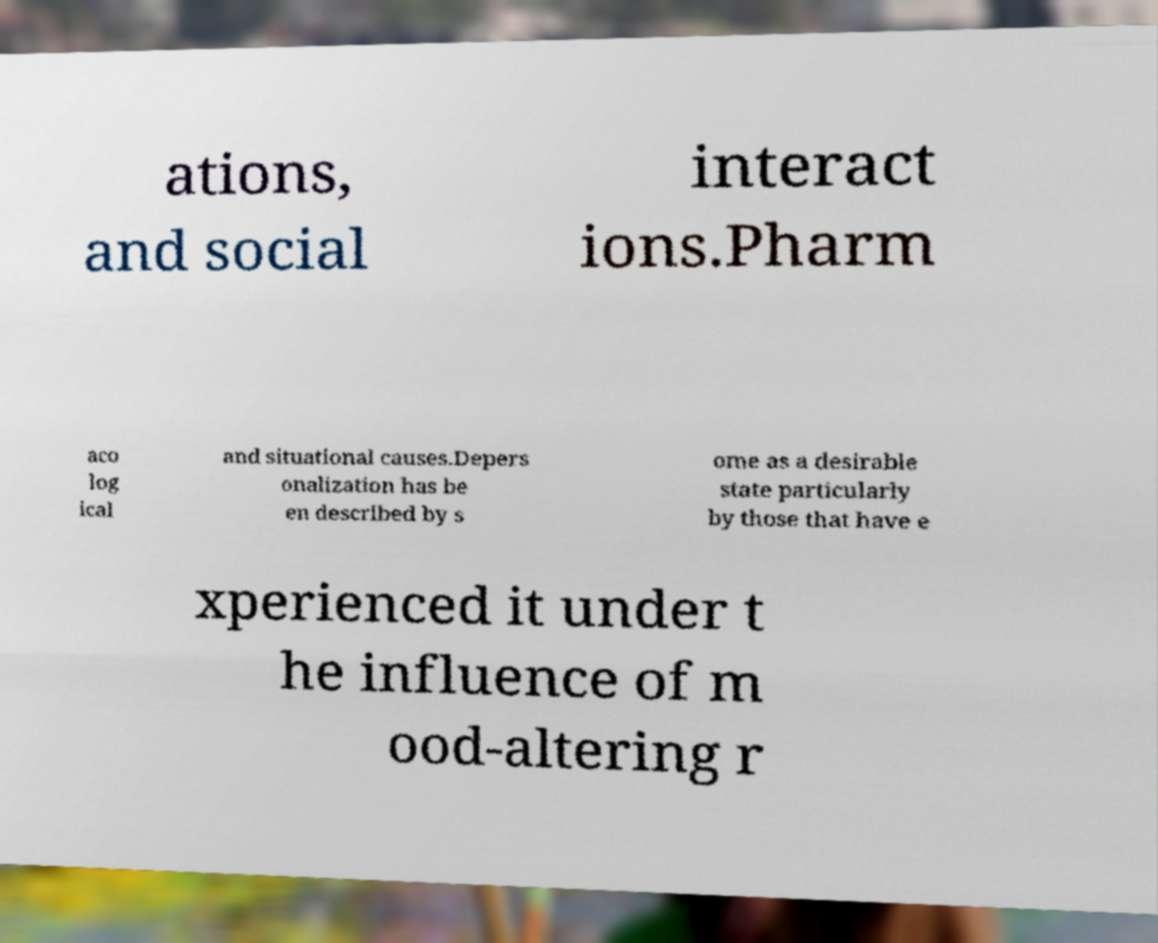There's text embedded in this image that I need extracted. Can you transcribe it verbatim? ations, and social interact ions.Pharm aco log ical and situational causes.Depers onalization has be en described by s ome as a desirable state particularly by those that have e xperienced it under t he influence of m ood-altering r 